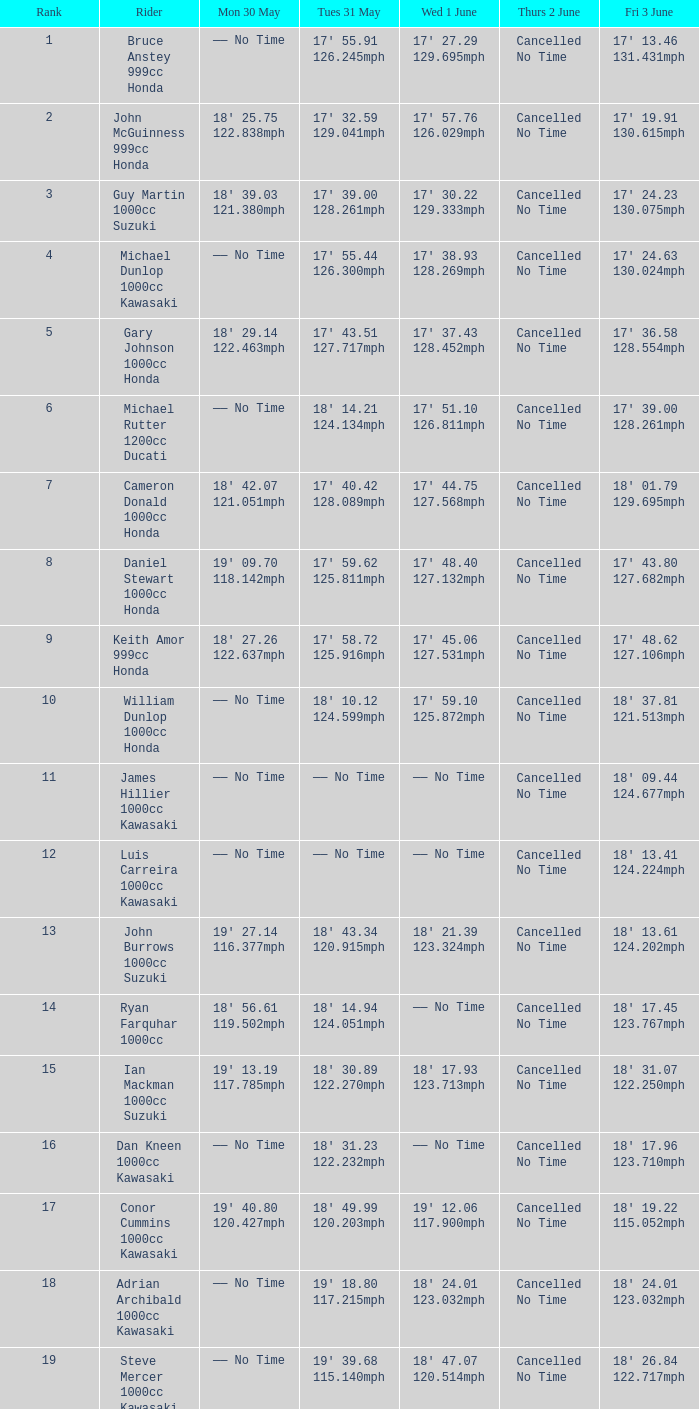Would you be able to parse every entry in this table? {'header': ['Rank', 'Rider', 'Mon 30 May', 'Tues 31 May', 'Wed 1 June', 'Thurs 2 June', 'Fri 3 June'], 'rows': [['1', 'Bruce Anstey 999cc Honda', '—— No Time', "17' 55.91 126.245mph", "17' 27.29 129.695mph", 'Cancelled No Time', "17' 13.46 131.431mph"], ['2', 'John McGuinness 999cc Honda', "18' 25.75 122.838mph", "17' 32.59 129.041mph", "17' 57.76 126.029mph", 'Cancelled No Time', "17' 19.91 130.615mph"], ['3', 'Guy Martin 1000cc Suzuki', "18' 39.03 121.380mph", "17' 39.00 128.261mph", "17' 30.22 129.333mph", 'Cancelled No Time', "17' 24.23 130.075mph"], ['4', 'Michael Dunlop 1000cc Kawasaki', '—— No Time', "17' 55.44 126.300mph", "17' 38.93 128.269mph", 'Cancelled No Time', "17' 24.63 130.024mph"], ['5', 'Gary Johnson 1000cc Honda', "18' 29.14 122.463mph", "17' 43.51 127.717mph", "17' 37.43 128.452mph", 'Cancelled No Time', "17' 36.58 128.554mph"], ['6', 'Michael Rutter 1200cc Ducati', '—— No Time', "18' 14.21 124.134mph", "17' 51.10 126.811mph", 'Cancelled No Time', "17' 39.00 128.261mph"], ['7', 'Cameron Donald 1000cc Honda', "18' 42.07 121.051mph", "17' 40.42 128.089mph", "17' 44.75 127.568mph", 'Cancelled No Time', "18' 01.79 129.695mph"], ['8', 'Daniel Stewart 1000cc Honda', "19' 09.70 118.142mph", "17' 59.62 125.811mph", "17' 48.40 127.132mph", 'Cancelled No Time', "17' 43.80 127.682mph"], ['9', 'Keith Amor 999cc Honda', "18' 27.26 122.637mph", "17' 58.72 125.916mph", "17' 45.06 127.531mph", 'Cancelled No Time', "17' 48.62 127.106mph"], ['10', 'William Dunlop 1000cc Honda', '—— No Time', "18' 10.12 124.599mph", "17' 59.10 125.872mph", 'Cancelled No Time', "18' 37.81 121.513mph"], ['11', 'James Hillier 1000cc Kawasaki', '—— No Time', '—— No Time', '—— No Time', 'Cancelled No Time', "18' 09.44 124.677mph"], ['12', 'Luis Carreira 1000cc Kawasaki', '—— No Time', '—— No Time', '—— No Time', 'Cancelled No Time', "18' 13.41 124.224mph"], ['13', 'John Burrows 1000cc Suzuki', "19' 27.14 116.377mph", "18' 43.34 120.915mph", "18' 21.39 123.324mph", 'Cancelled No Time', "18' 13.61 124.202mph"], ['14', 'Ryan Farquhar 1000cc', "18' 56.61 119.502mph", "18' 14.94 124.051mph", '—— No Time', 'Cancelled No Time', "18' 17.45 123.767mph"], ['15', 'Ian Mackman 1000cc Suzuki', "19' 13.19 117.785mph", "18' 30.89 122.270mph", "18' 17.93 123.713mph", 'Cancelled No Time', "18' 31.07 122.250mph"], ['16', 'Dan Kneen 1000cc Kawasaki', '—— No Time', "18' 31.23 122.232mph", '—— No Time', 'Cancelled No Time', "18' 17.96 123.710mph"], ['17', 'Conor Cummins 1000cc Kawasaki', "19' 40.80 120.427mph", "18' 49.99 120.203mph", "19' 12.06 117.900mph", 'Cancelled No Time', "18' 19.22 115.052mph"], ['18', 'Adrian Archibald 1000cc Kawasaki', '—— No Time', "19' 18.80 117.215mph", "18' 24.01 123.032mph", 'Cancelled No Time', "18' 24.01 123.032mph"], ['19', 'Steve Mercer 1000cc Kawasaki', '—— No Time', "19' 39.68 115.140mph", "18' 47.07 120.514mph", 'Cancelled No Time', "18' 26.84 122.717mph"]]} 46 13 —— No Time. 